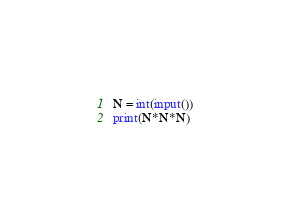<code> <loc_0><loc_0><loc_500><loc_500><_Python_>N = int(input())
print(N*N*N)</code> 